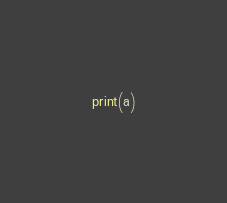<code> <loc_0><loc_0><loc_500><loc_500><_Python_>print(a)</code> 